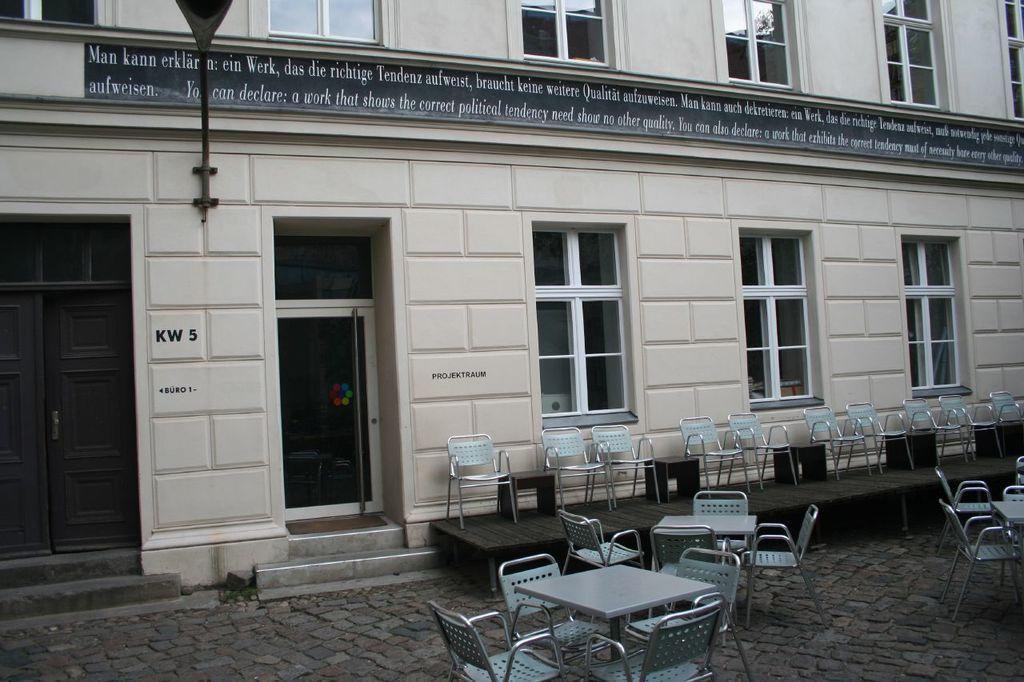Describe this image in one or two sentences. In this image, we can see chairs and tables and there are stools and a stage. In the background, there are windows and a light to the building. 